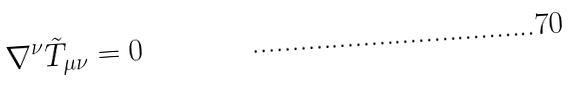<formula> <loc_0><loc_0><loc_500><loc_500>\nabla ^ { \nu } \tilde { T } _ { \mu \nu } = 0</formula> 